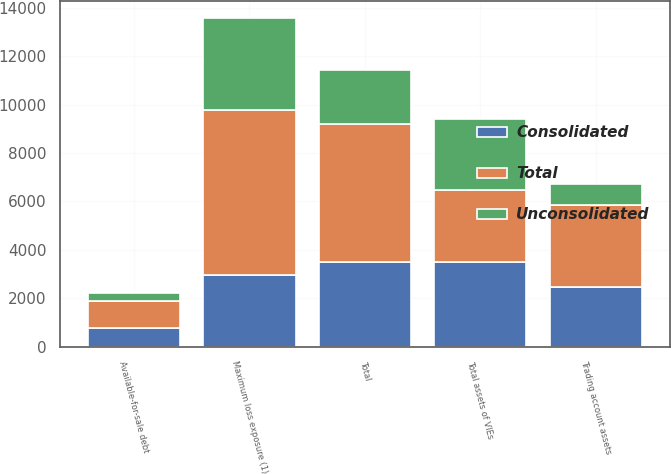Convert chart. <chart><loc_0><loc_0><loc_500><loc_500><stacked_bar_chart><ecel><fcel>Maximum loss exposure (1)<fcel>Trading account assets<fcel>Available-for-sale debt<fcel>Total<fcel>Total assets of VIEs<nl><fcel>Consolidated<fcel>2971<fcel>2485<fcel>769<fcel>3485<fcel>3485<nl><fcel>Unconsolidated<fcel>3828<fcel>884<fcel>338<fcel>2235<fcel>2971<nl><fcel>Total<fcel>6799<fcel>3369<fcel>1107<fcel>5720<fcel>2971<nl></chart> 